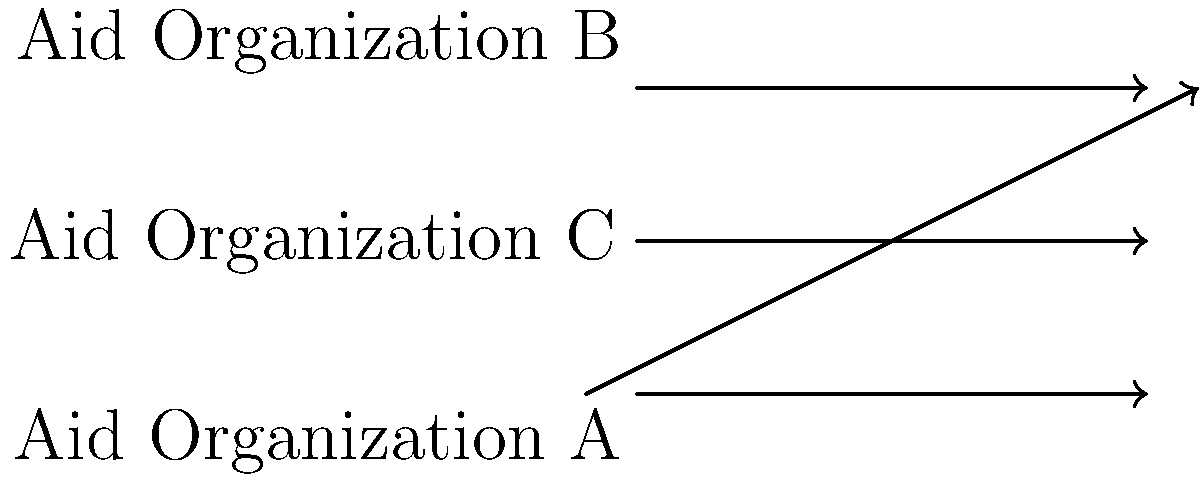In the diagram, three parallel lines represent different aid organizations working towards a shared goal. The transversal line represents the path to achieving this goal. If the angle formed by Organization A's line and the transversal is 40°, and the angles $x°$ and $y°$ are formed by the transversal with Organizations B and C respectively, what is the value of $x + y$? Let's approach this step-by-step:

1) In geometry, when a transversal crosses parallel lines, corresponding angles are equal. This principle applies to our aid organizations scenario.

2) We're given that the angle formed by Organization A's line and the transversal is 40°. This means its alternate interior angle (the one that forms $y°$ with the transversal) is also 40°.

3) In a straight line, angles sum to 180°. Therefore:

   $y° + 40° = 180°$
   $y° = 180° - 40° = 140°$

4) Now, for the angle $x°$, we can use the same principle. The alternate interior angle to $x°$ (the one formed with Organization C's line) is equal to $y°$.

5) Again, using the straight line principle:

   $x° + 140° = 180°$
   $x° = 180° - 140° = 40°$

6) The question asks for $x + y$:

   $x + y = 40° + 140° = 180°$

This result symbolizes how different aid organizations, despite their parallel (separate) operations, align their efforts towards a common goal, forming a complete (180°) approach to addressing global issues.
Answer: 180° 